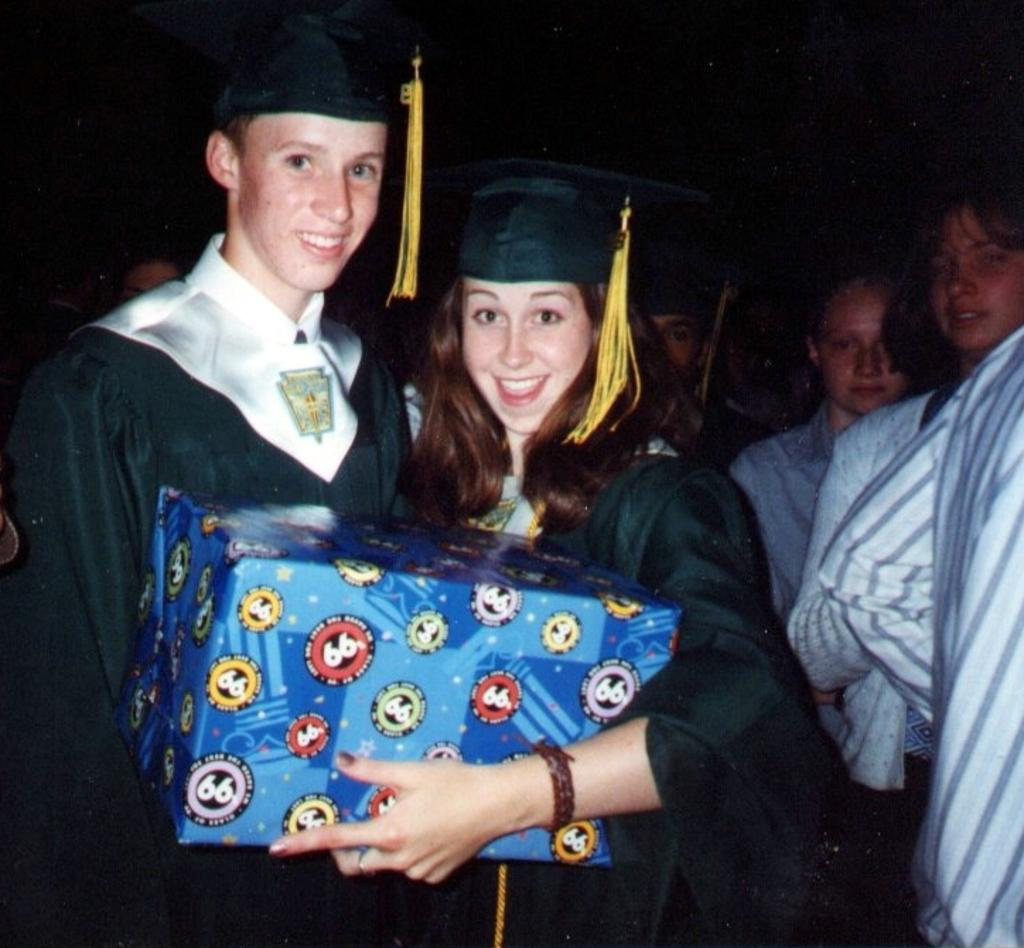How many people are in the image? There are a few people in the image. What is one person doing in the image? One person is holding an object. Can you describe the background of the image? The background of the image is blurred. What type of discovery can be seen on the desk in the image? There is no desk present in the image, and therefore no discovery can be seen on it. 